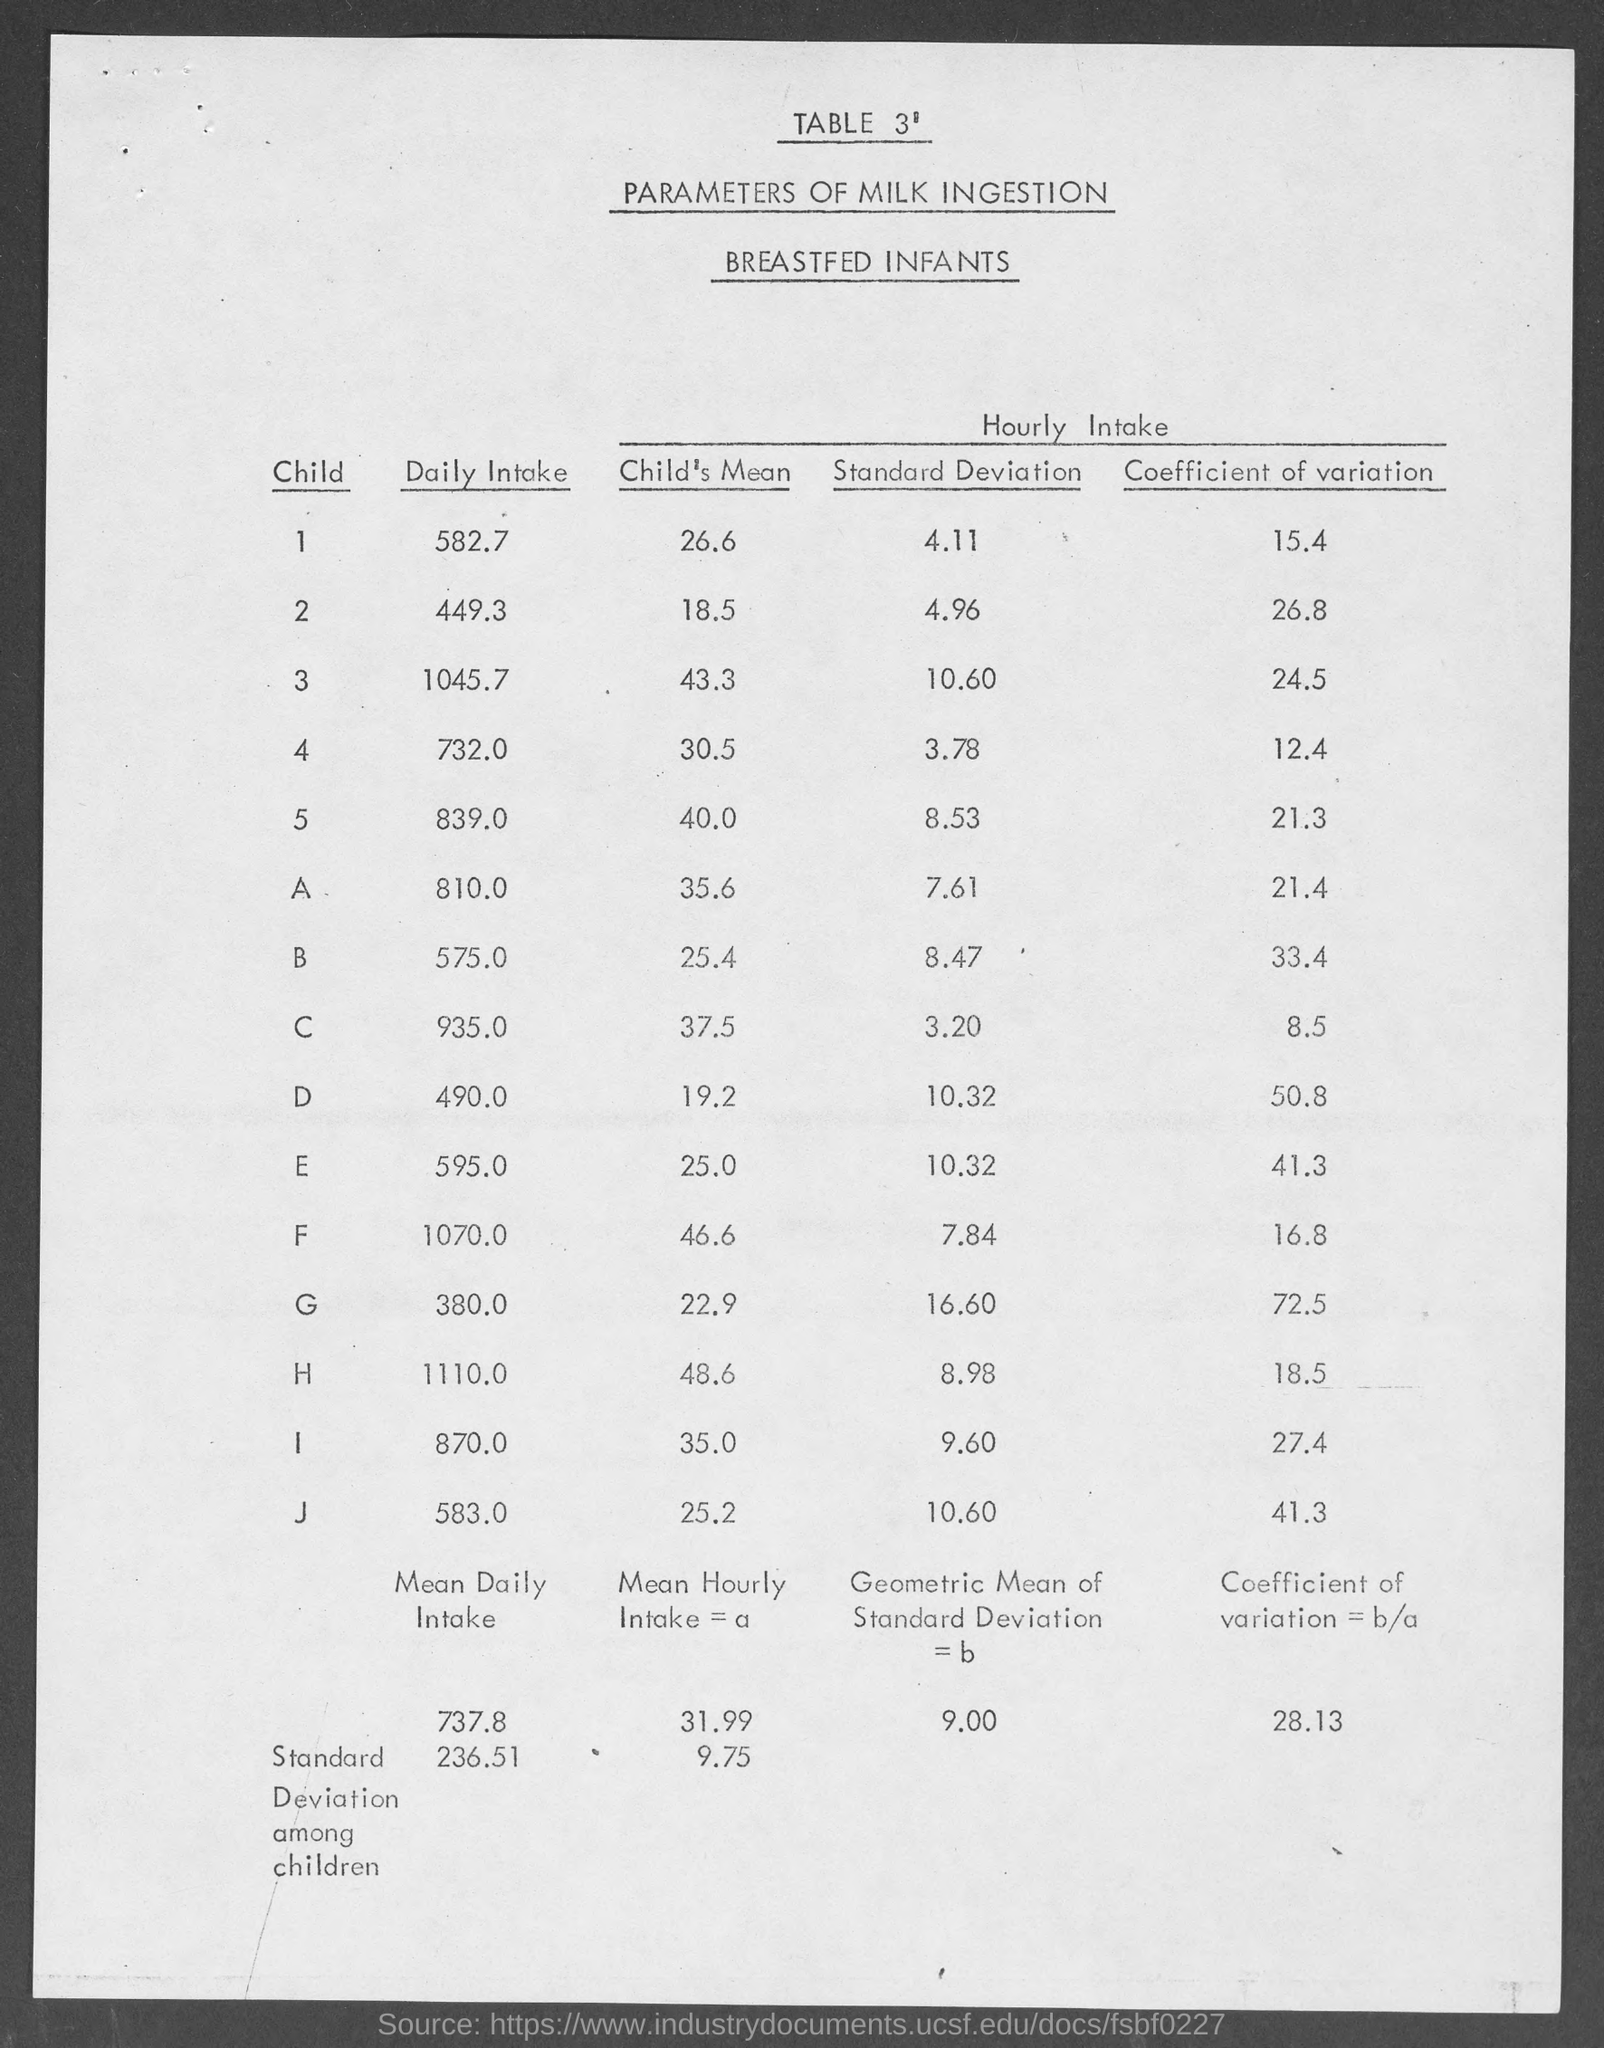What is the table number?
Keep it short and to the point. 3'. What is the first column heading of the table?
Provide a succinct answer. CHILD. What is the Daily intake of milk of the first child ?
Provide a short and direct response. 582 7. 